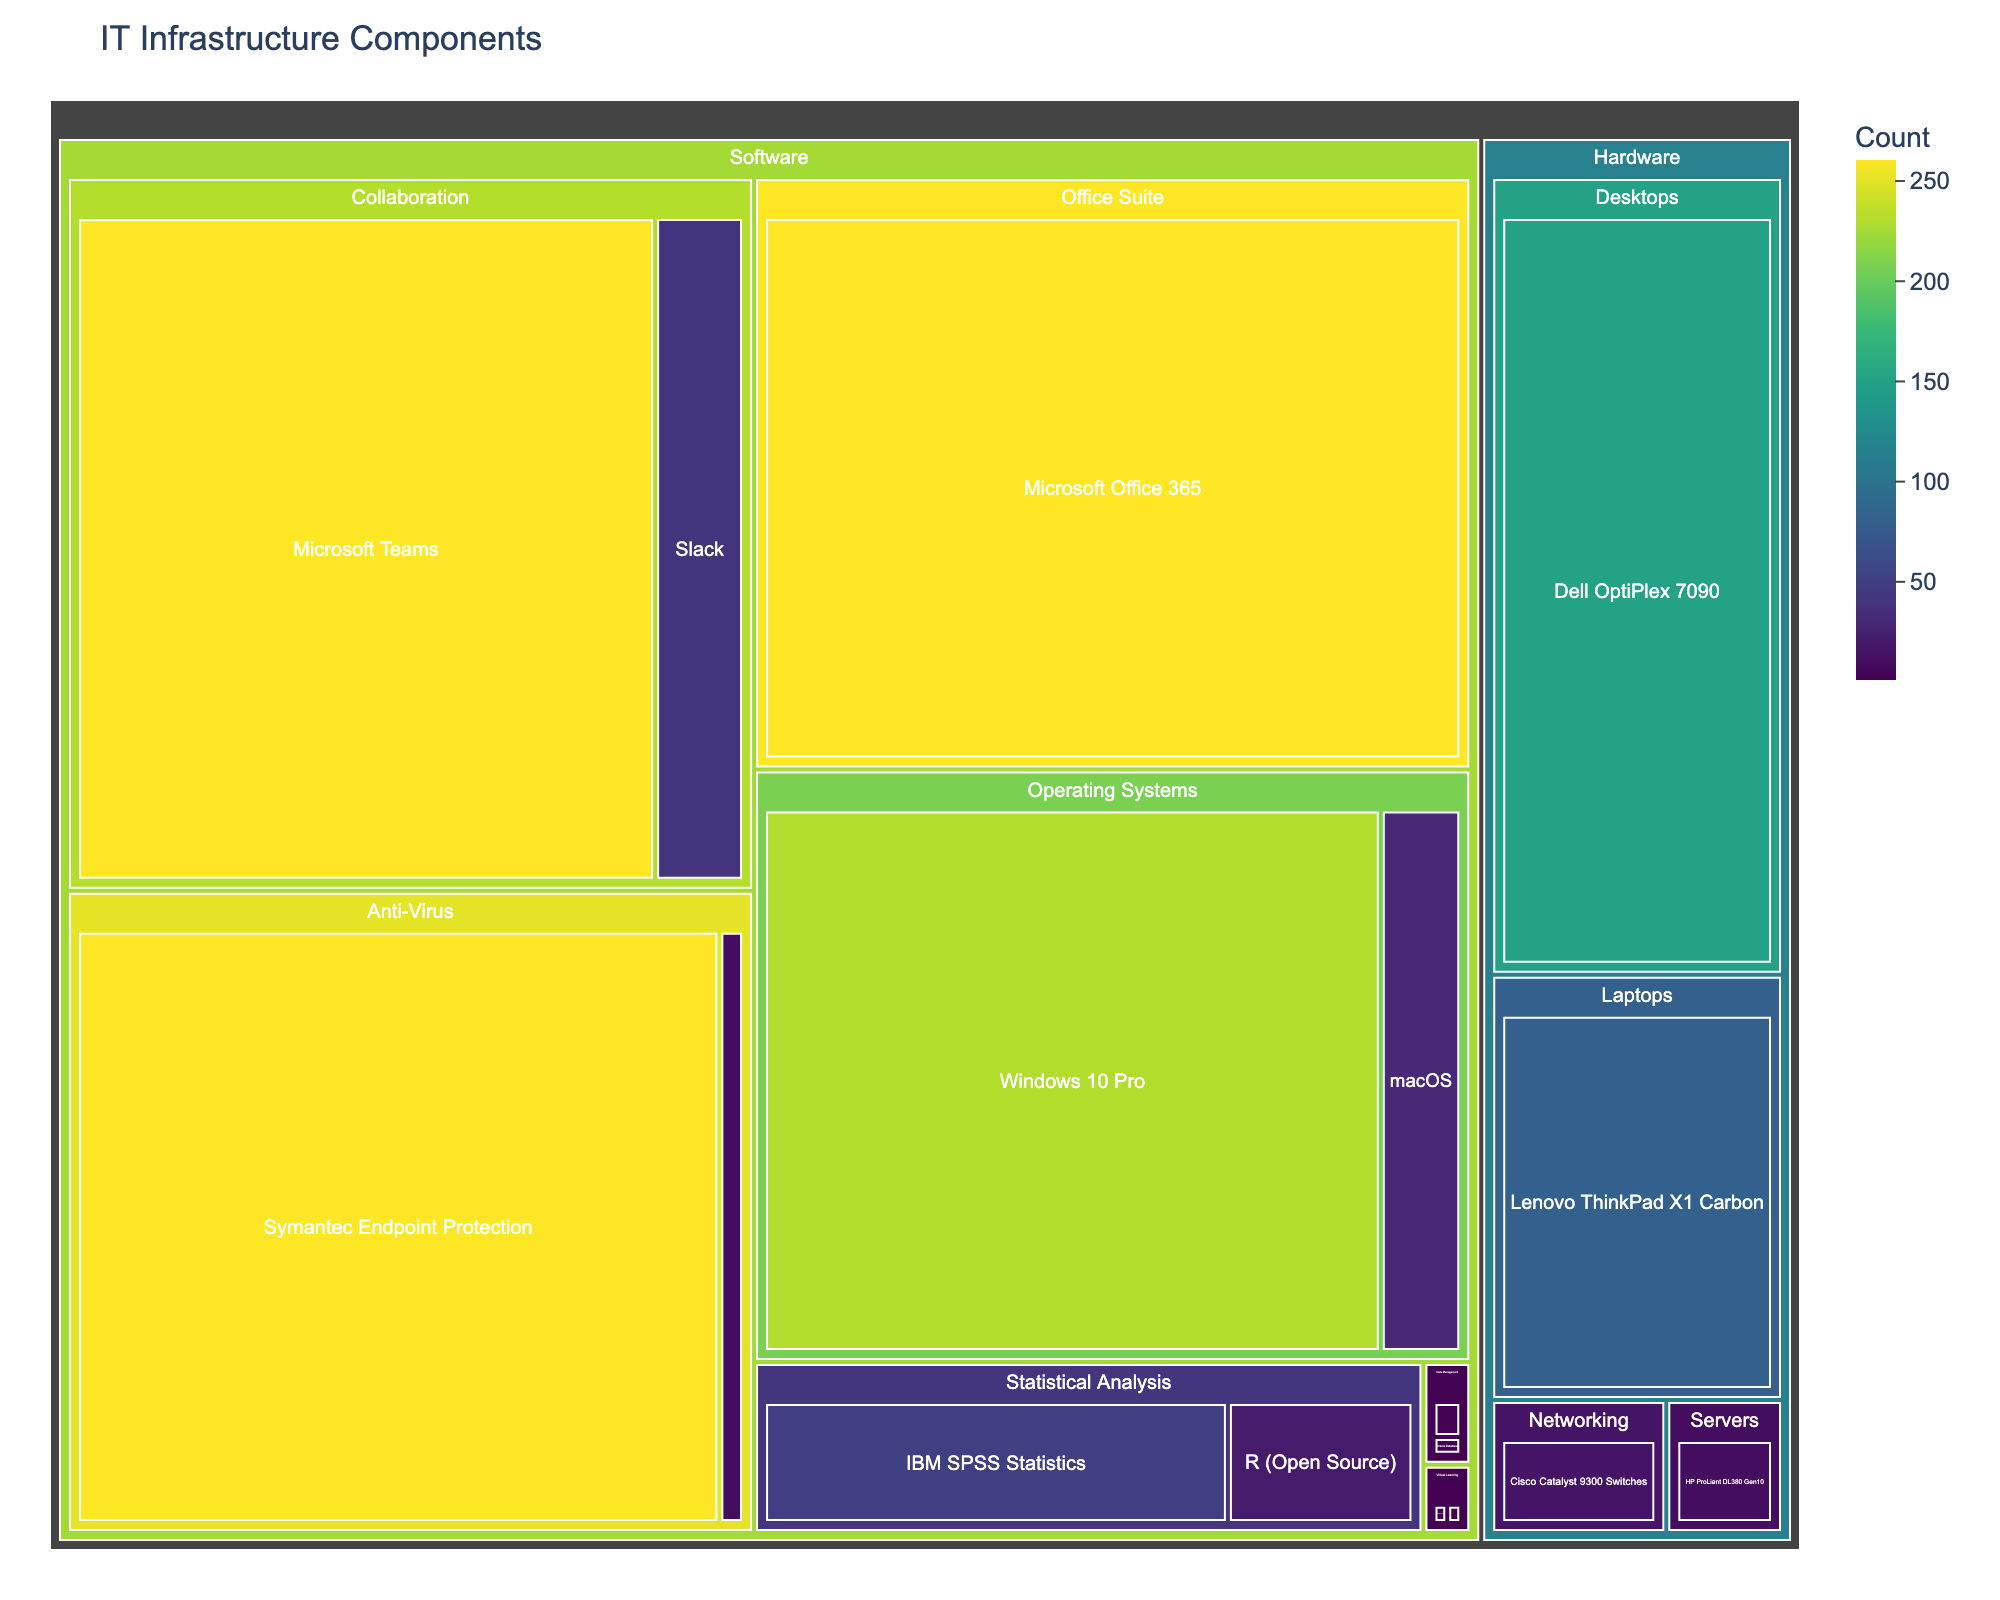How many items are in the hardware category? To determine the number of items in the hardware category, look for all subcategories under "Hardware" and count the items. There are Desktops (1 item), Laptops (1 item), Servers (1 item), and Networking (1 item).
Answer: 4 What is the total count of items in the software category? First, identify all items under the "Software" category and their counts. Add them up: Windows 10 Pro (230), macOS (30), Microsoft Office 365 (260), IBM SPSS Statistics (50), R (20), Oracle Database (1), MySQL (2), Microsoft Teams (260), Slack (40), Blackboard Learn (1), Moodle (1), Symantec Endpoint Protection (260), ClamAV (10). The total is 230+30+260+50+20+1+2+260+40+1+1+260+10.
Answer: 1165 Which item has the highest count in the software category? In the software category, compare the values of all items. The item with the highest value is "Microsoft Office 365" with a count of 260.
Answer: Microsoft Office 365 How does the count of proprietary statistical analysis software compare to the open-source alternative? Under the "Statistical Analysis" subcategory, compare the count of "IBM SPSS Statistics" (50) to "R (Open Source)" (20).
Answer: IBM SPSS Statistics is higher by 30 What is the combined count of counts for open-source alternatives in all software subcategories? Identify the counts for all open-source alternatives: R (20), MySQL (2), Moodle (1), and ClamAV (10). Sum them up: 20+2+1+10.
Answer: 33 Which category has the lowest count in the hardware section? Compare the counts for each item in the hardware section: Dell OptiPlex 7090 (150), Lenovo ThinkPad X1 Carbon (80), HP ProLiant DL380 Gen10 (10), Cisco Catalyst 9300 Switches (15).
Answer: Servers (10) What is the ratio of the count of Microsoft Teams to Slack in the collaboration subcategory? Find the counts for "Microsoft Teams" (260) and "Slack" (40). Calculate the ratio: 260 / 40.
Answer: 6.5 How many items are proprietary software compared to open-source in the virtual learning subcategory? In the "Virtual Learning" subcategory, identify the proprietary software "Blackboard Learn" (1) and the open-source "Moodle" (1). The count for both is the same.
Answer: 1 proprietary, 1 open-source What is the proportion of counts of proprietary operating systems compared to open-source alternatives in the software category? In the "Operating Systems" subcategory, compare "Windows 10 Pro" (230) and "macOS" (30) against the sum of all open-source alternatives. No open-source operating systems are listed, so compare against the total software counts. Both are proprietary.
Answer: 100% proprietary 